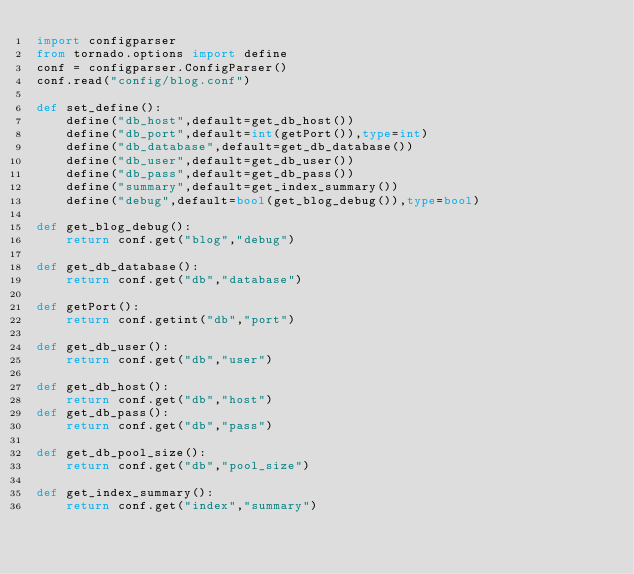Convert code to text. <code><loc_0><loc_0><loc_500><loc_500><_Python_>import configparser
from tornado.options import define
conf = configparser.ConfigParser()
conf.read("config/blog.conf")

def set_define():
    define("db_host",default=get_db_host())
    define("db_port",default=int(getPort()),type=int)
    define("db_database",default=get_db_database())
    define("db_user",default=get_db_user())
    define("db_pass",default=get_db_pass())
    define("summary",default=get_index_summary())
    define("debug",default=bool(get_blog_debug()),type=bool)

def get_blog_debug():
    return conf.get("blog","debug")

def get_db_database():
    return conf.get("db","database")

def getPort():
    return conf.getint("db","port")

def get_db_user():
    return conf.get("db","user")

def get_db_host():
    return conf.get("db","host")
def get_db_pass():
    return conf.get("db","pass")

def get_db_pool_size():
    return conf.get("db","pool_size")

def get_index_summary():
    return conf.get("index","summary")</code> 